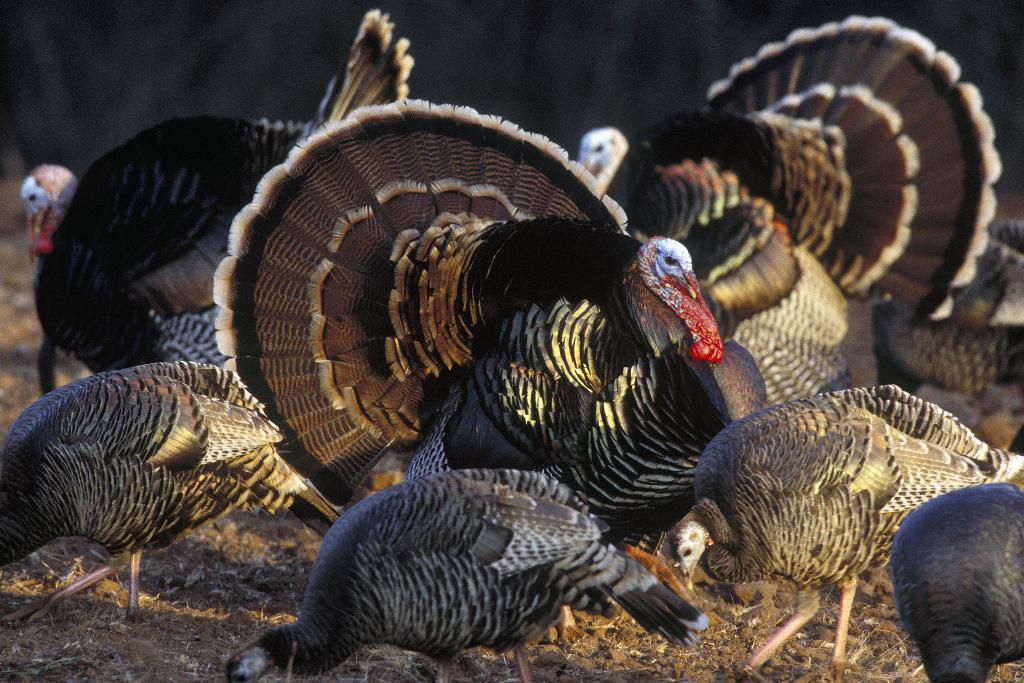What type of animals can be seen in the image? Birds can be seen in the image. What type of thrill can be experienced by the ghost riding the trains in the image? There is no ghost or trains present in the image, and therefore no such activity can be observed. 